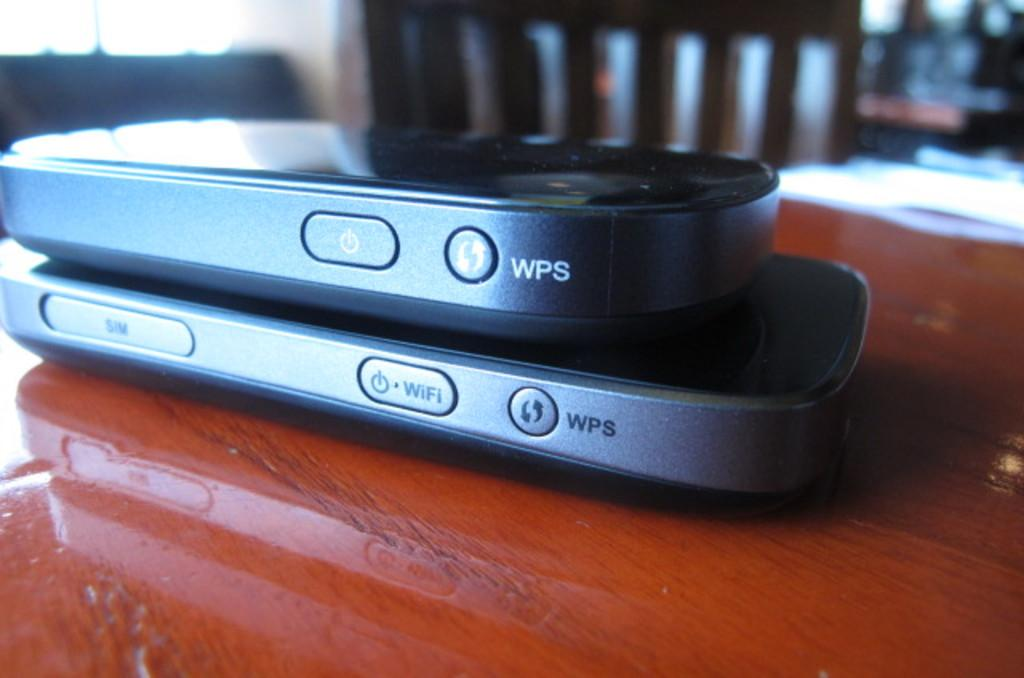<image>
Present a compact description of the photo's key features. small electronic devices labeled with the word 'wps' on both 